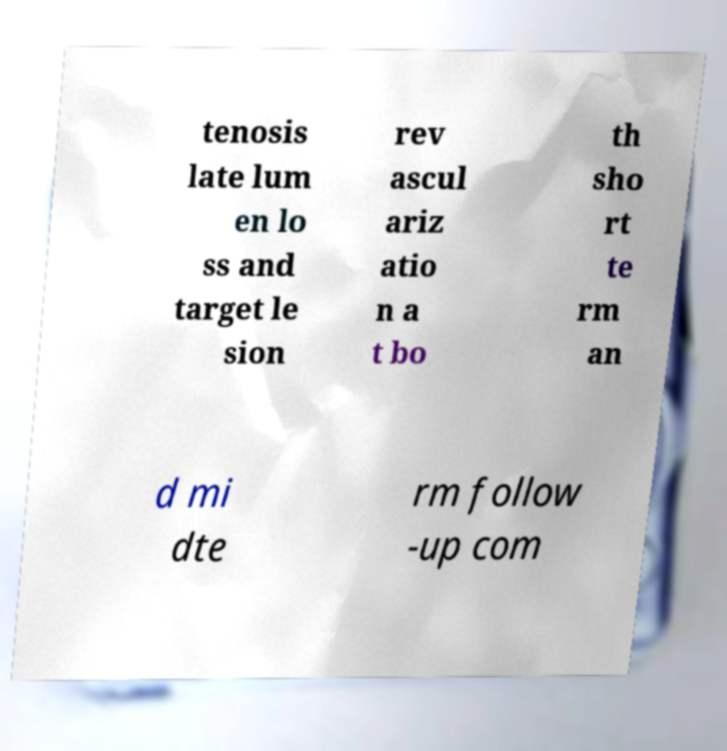Can you accurately transcribe the text from the provided image for me? tenosis late lum en lo ss and target le sion rev ascul ariz atio n a t bo th sho rt te rm an d mi dte rm follow -up com 